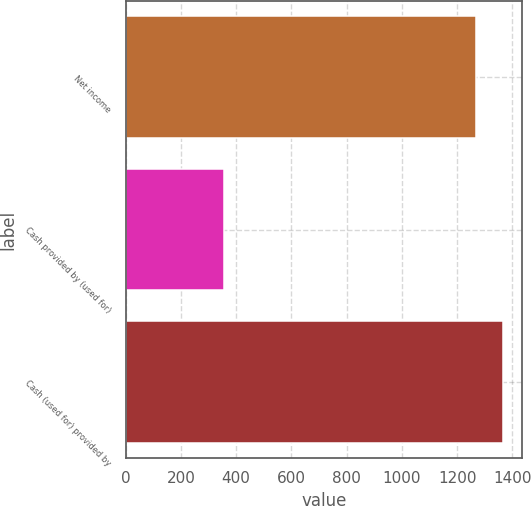Convert chart to OTSL. <chart><loc_0><loc_0><loc_500><loc_500><bar_chart><fcel>Net income<fcel>Cash provided by (used for)<fcel>Cash (used for) provided by<nl><fcel>1268<fcel>356<fcel>1367.3<nl></chart> 